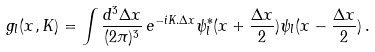<formula> <loc_0><loc_0><loc_500><loc_500>g _ { l } ( { x } , { K } ) = \int \frac { d ^ { 3 } \Delta x } { ( 2 \pi ) ^ { 3 } } \, e ^ { - i { K } . { \Delta x } } \psi _ { l } ^ { * } ( { x } + \frac { \Delta x } { 2 } ) \psi _ { l } ( { x } - \frac { \Delta x } { 2 } ) \, .</formula> 